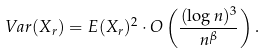Convert formula to latex. <formula><loc_0><loc_0><loc_500><loc_500>V a r ( X _ { r } ) = E ( X _ { r } ) ^ { 2 } \cdot O \left ( \frac { ( \log n ) ^ { 3 } } { n ^ { \beta } } \right ) .</formula> 